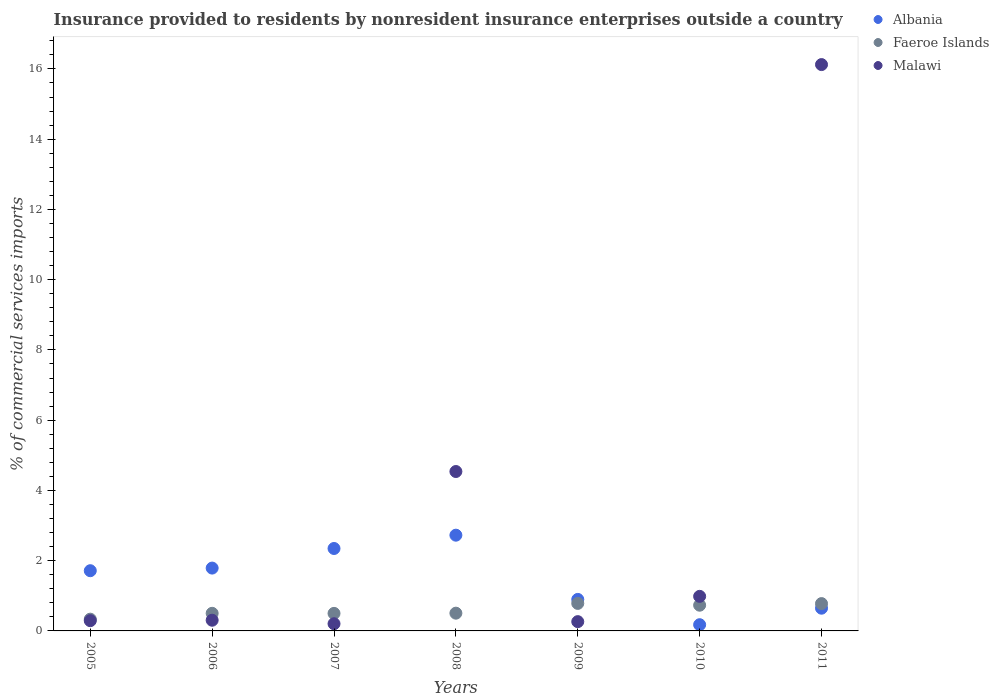How many different coloured dotlines are there?
Offer a very short reply. 3. What is the Insurance provided to residents in Malawi in 2006?
Provide a short and direct response. 0.3. Across all years, what is the maximum Insurance provided to residents in Faeroe Islands?
Keep it short and to the point. 0.78. Across all years, what is the minimum Insurance provided to residents in Faeroe Islands?
Provide a succinct answer. 0.33. In which year was the Insurance provided to residents in Faeroe Islands maximum?
Give a very brief answer. 2009. What is the total Insurance provided to residents in Faeroe Islands in the graph?
Give a very brief answer. 4.13. What is the difference between the Insurance provided to residents in Albania in 2005 and that in 2008?
Your response must be concise. -1.01. What is the difference between the Insurance provided to residents in Albania in 2008 and the Insurance provided to residents in Faeroe Islands in 2007?
Keep it short and to the point. 2.23. What is the average Insurance provided to residents in Malawi per year?
Provide a short and direct response. 3.24. In the year 2007, what is the difference between the Insurance provided to residents in Albania and Insurance provided to residents in Faeroe Islands?
Your response must be concise. 1.85. What is the ratio of the Insurance provided to residents in Faeroe Islands in 2007 to that in 2009?
Keep it short and to the point. 0.64. Is the Insurance provided to residents in Faeroe Islands in 2008 less than that in 2011?
Offer a terse response. Yes. What is the difference between the highest and the second highest Insurance provided to residents in Albania?
Provide a short and direct response. 0.38. What is the difference between the highest and the lowest Insurance provided to residents in Malawi?
Give a very brief answer. 15.92. In how many years, is the Insurance provided to residents in Malawi greater than the average Insurance provided to residents in Malawi taken over all years?
Ensure brevity in your answer.  2. Is the sum of the Insurance provided to residents in Albania in 2005 and 2010 greater than the maximum Insurance provided to residents in Malawi across all years?
Give a very brief answer. No. How many dotlines are there?
Make the answer very short. 3. How many years are there in the graph?
Offer a terse response. 7. Are the values on the major ticks of Y-axis written in scientific E-notation?
Your response must be concise. No. What is the title of the graph?
Offer a very short reply. Insurance provided to residents by nonresident insurance enterprises outside a country. What is the label or title of the X-axis?
Offer a terse response. Years. What is the label or title of the Y-axis?
Keep it short and to the point. % of commercial services imports. What is the % of commercial services imports of Albania in 2005?
Make the answer very short. 1.71. What is the % of commercial services imports of Faeroe Islands in 2005?
Your answer should be compact. 0.33. What is the % of commercial services imports in Malawi in 2005?
Offer a very short reply. 0.29. What is the % of commercial services imports in Albania in 2006?
Provide a short and direct response. 1.79. What is the % of commercial services imports of Faeroe Islands in 2006?
Your response must be concise. 0.5. What is the % of commercial services imports in Malawi in 2006?
Offer a terse response. 0.3. What is the % of commercial services imports of Albania in 2007?
Make the answer very short. 2.35. What is the % of commercial services imports of Faeroe Islands in 2007?
Give a very brief answer. 0.5. What is the % of commercial services imports of Malawi in 2007?
Provide a succinct answer. 0.2. What is the % of commercial services imports of Albania in 2008?
Your response must be concise. 2.73. What is the % of commercial services imports in Faeroe Islands in 2008?
Your answer should be very brief. 0.51. What is the % of commercial services imports of Malawi in 2008?
Ensure brevity in your answer.  4.54. What is the % of commercial services imports of Albania in 2009?
Ensure brevity in your answer.  0.9. What is the % of commercial services imports in Faeroe Islands in 2009?
Your answer should be very brief. 0.78. What is the % of commercial services imports in Malawi in 2009?
Provide a succinct answer. 0.26. What is the % of commercial services imports in Albania in 2010?
Your response must be concise. 0.18. What is the % of commercial services imports of Faeroe Islands in 2010?
Ensure brevity in your answer.  0.73. What is the % of commercial services imports in Malawi in 2010?
Your response must be concise. 0.98. What is the % of commercial services imports of Albania in 2011?
Ensure brevity in your answer.  0.65. What is the % of commercial services imports in Faeroe Islands in 2011?
Offer a very short reply. 0.78. What is the % of commercial services imports of Malawi in 2011?
Offer a terse response. 16.12. Across all years, what is the maximum % of commercial services imports of Albania?
Provide a short and direct response. 2.73. Across all years, what is the maximum % of commercial services imports of Faeroe Islands?
Your response must be concise. 0.78. Across all years, what is the maximum % of commercial services imports of Malawi?
Your response must be concise. 16.12. Across all years, what is the minimum % of commercial services imports of Albania?
Your answer should be very brief. 0.18. Across all years, what is the minimum % of commercial services imports in Faeroe Islands?
Ensure brevity in your answer.  0.33. Across all years, what is the minimum % of commercial services imports of Malawi?
Offer a very short reply. 0.2. What is the total % of commercial services imports in Albania in the graph?
Your answer should be compact. 10.3. What is the total % of commercial services imports in Faeroe Islands in the graph?
Give a very brief answer. 4.13. What is the total % of commercial services imports in Malawi in the graph?
Your answer should be very brief. 22.71. What is the difference between the % of commercial services imports in Albania in 2005 and that in 2006?
Offer a terse response. -0.07. What is the difference between the % of commercial services imports of Faeroe Islands in 2005 and that in 2006?
Your answer should be very brief. -0.17. What is the difference between the % of commercial services imports of Malawi in 2005 and that in 2006?
Offer a terse response. -0.01. What is the difference between the % of commercial services imports in Albania in 2005 and that in 2007?
Provide a short and direct response. -0.63. What is the difference between the % of commercial services imports in Faeroe Islands in 2005 and that in 2007?
Offer a very short reply. -0.16. What is the difference between the % of commercial services imports of Malawi in 2005 and that in 2007?
Offer a very short reply. 0.09. What is the difference between the % of commercial services imports of Albania in 2005 and that in 2008?
Give a very brief answer. -1.01. What is the difference between the % of commercial services imports of Faeroe Islands in 2005 and that in 2008?
Your answer should be compact. -0.17. What is the difference between the % of commercial services imports in Malawi in 2005 and that in 2008?
Your response must be concise. -4.25. What is the difference between the % of commercial services imports in Albania in 2005 and that in 2009?
Give a very brief answer. 0.82. What is the difference between the % of commercial services imports in Faeroe Islands in 2005 and that in 2009?
Offer a very short reply. -0.45. What is the difference between the % of commercial services imports in Malawi in 2005 and that in 2009?
Give a very brief answer. 0.03. What is the difference between the % of commercial services imports in Albania in 2005 and that in 2010?
Provide a succinct answer. 1.54. What is the difference between the % of commercial services imports of Faeroe Islands in 2005 and that in 2010?
Make the answer very short. -0.4. What is the difference between the % of commercial services imports in Malawi in 2005 and that in 2010?
Offer a terse response. -0.69. What is the difference between the % of commercial services imports of Albania in 2005 and that in 2011?
Your response must be concise. 1.07. What is the difference between the % of commercial services imports in Faeroe Islands in 2005 and that in 2011?
Your answer should be compact. -0.44. What is the difference between the % of commercial services imports of Malawi in 2005 and that in 2011?
Give a very brief answer. -15.83. What is the difference between the % of commercial services imports in Albania in 2006 and that in 2007?
Give a very brief answer. -0.56. What is the difference between the % of commercial services imports in Faeroe Islands in 2006 and that in 2007?
Keep it short and to the point. 0. What is the difference between the % of commercial services imports of Malawi in 2006 and that in 2007?
Make the answer very short. 0.1. What is the difference between the % of commercial services imports of Albania in 2006 and that in 2008?
Provide a succinct answer. -0.94. What is the difference between the % of commercial services imports of Faeroe Islands in 2006 and that in 2008?
Make the answer very short. -0. What is the difference between the % of commercial services imports in Malawi in 2006 and that in 2008?
Your answer should be compact. -4.23. What is the difference between the % of commercial services imports in Albania in 2006 and that in 2009?
Offer a terse response. 0.89. What is the difference between the % of commercial services imports in Faeroe Islands in 2006 and that in 2009?
Keep it short and to the point. -0.28. What is the difference between the % of commercial services imports of Malawi in 2006 and that in 2009?
Provide a short and direct response. 0.04. What is the difference between the % of commercial services imports of Albania in 2006 and that in 2010?
Your response must be concise. 1.61. What is the difference between the % of commercial services imports of Faeroe Islands in 2006 and that in 2010?
Offer a terse response. -0.23. What is the difference between the % of commercial services imports of Malawi in 2006 and that in 2010?
Your answer should be very brief. -0.68. What is the difference between the % of commercial services imports in Albania in 2006 and that in 2011?
Provide a short and direct response. 1.14. What is the difference between the % of commercial services imports of Faeroe Islands in 2006 and that in 2011?
Offer a very short reply. -0.28. What is the difference between the % of commercial services imports in Malawi in 2006 and that in 2011?
Make the answer very short. -15.82. What is the difference between the % of commercial services imports in Albania in 2007 and that in 2008?
Give a very brief answer. -0.38. What is the difference between the % of commercial services imports in Faeroe Islands in 2007 and that in 2008?
Keep it short and to the point. -0.01. What is the difference between the % of commercial services imports in Malawi in 2007 and that in 2008?
Make the answer very short. -4.33. What is the difference between the % of commercial services imports in Albania in 2007 and that in 2009?
Your answer should be compact. 1.45. What is the difference between the % of commercial services imports in Faeroe Islands in 2007 and that in 2009?
Offer a terse response. -0.28. What is the difference between the % of commercial services imports of Malawi in 2007 and that in 2009?
Your answer should be very brief. -0.06. What is the difference between the % of commercial services imports in Albania in 2007 and that in 2010?
Make the answer very short. 2.17. What is the difference between the % of commercial services imports of Faeroe Islands in 2007 and that in 2010?
Give a very brief answer. -0.23. What is the difference between the % of commercial services imports of Malawi in 2007 and that in 2010?
Make the answer very short. -0.78. What is the difference between the % of commercial services imports of Albania in 2007 and that in 2011?
Your answer should be very brief. 1.7. What is the difference between the % of commercial services imports of Faeroe Islands in 2007 and that in 2011?
Provide a succinct answer. -0.28. What is the difference between the % of commercial services imports of Malawi in 2007 and that in 2011?
Your response must be concise. -15.92. What is the difference between the % of commercial services imports in Albania in 2008 and that in 2009?
Give a very brief answer. 1.83. What is the difference between the % of commercial services imports in Faeroe Islands in 2008 and that in 2009?
Offer a very short reply. -0.28. What is the difference between the % of commercial services imports of Malawi in 2008 and that in 2009?
Keep it short and to the point. 4.27. What is the difference between the % of commercial services imports of Albania in 2008 and that in 2010?
Provide a succinct answer. 2.55. What is the difference between the % of commercial services imports in Faeroe Islands in 2008 and that in 2010?
Your response must be concise. -0.23. What is the difference between the % of commercial services imports in Malawi in 2008 and that in 2010?
Provide a short and direct response. 3.55. What is the difference between the % of commercial services imports in Albania in 2008 and that in 2011?
Keep it short and to the point. 2.08. What is the difference between the % of commercial services imports of Faeroe Islands in 2008 and that in 2011?
Your response must be concise. -0.27. What is the difference between the % of commercial services imports of Malawi in 2008 and that in 2011?
Keep it short and to the point. -11.59. What is the difference between the % of commercial services imports of Albania in 2009 and that in 2010?
Your answer should be very brief. 0.72. What is the difference between the % of commercial services imports of Faeroe Islands in 2009 and that in 2010?
Provide a short and direct response. 0.05. What is the difference between the % of commercial services imports of Malawi in 2009 and that in 2010?
Provide a short and direct response. -0.72. What is the difference between the % of commercial services imports of Albania in 2009 and that in 2011?
Keep it short and to the point. 0.25. What is the difference between the % of commercial services imports in Faeroe Islands in 2009 and that in 2011?
Give a very brief answer. 0.01. What is the difference between the % of commercial services imports of Malawi in 2009 and that in 2011?
Ensure brevity in your answer.  -15.86. What is the difference between the % of commercial services imports in Albania in 2010 and that in 2011?
Offer a very short reply. -0.47. What is the difference between the % of commercial services imports in Faeroe Islands in 2010 and that in 2011?
Offer a terse response. -0.05. What is the difference between the % of commercial services imports in Malawi in 2010 and that in 2011?
Your response must be concise. -15.14. What is the difference between the % of commercial services imports in Albania in 2005 and the % of commercial services imports in Faeroe Islands in 2006?
Ensure brevity in your answer.  1.21. What is the difference between the % of commercial services imports in Albania in 2005 and the % of commercial services imports in Malawi in 2006?
Keep it short and to the point. 1.41. What is the difference between the % of commercial services imports in Faeroe Islands in 2005 and the % of commercial services imports in Malawi in 2006?
Ensure brevity in your answer.  0.03. What is the difference between the % of commercial services imports in Albania in 2005 and the % of commercial services imports in Faeroe Islands in 2007?
Your answer should be compact. 1.22. What is the difference between the % of commercial services imports in Albania in 2005 and the % of commercial services imports in Malawi in 2007?
Give a very brief answer. 1.51. What is the difference between the % of commercial services imports of Faeroe Islands in 2005 and the % of commercial services imports of Malawi in 2007?
Ensure brevity in your answer.  0.13. What is the difference between the % of commercial services imports of Albania in 2005 and the % of commercial services imports of Faeroe Islands in 2008?
Your answer should be compact. 1.21. What is the difference between the % of commercial services imports in Albania in 2005 and the % of commercial services imports in Malawi in 2008?
Provide a short and direct response. -2.82. What is the difference between the % of commercial services imports in Faeroe Islands in 2005 and the % of commercial services imports in Malawi in 2008?
Your response must be concise. -4.2. What is the difference between the % of commercial services imports of Albania in 2005 and the % of commercial services imports of Faeroe Islands in 2009?
Provide a succinct answer. 0.93. What is the difference between the % of commercial services imports in Albania in 2005 and the % of commercial services imports in Malawi in 2009?
Give a very brief answer. 1.45. What is the difference between the % of commercial services imports in Faeroe Islands in 2005 and the % of commercial services imports in Malawi in 2009?
Ensure brevity in your answer.  0.07. What is the difference between the % of commercial services imports in Albania in 2005 and the % of commercial services imports in Faeroe Islands in 2010?
Ensure brevity in your answer.  0.98. What is the difference between the % of commercial services imports in Albania in 2005 and the % of commercial services imports in Malawi in 2010?
Your answer should be very brief. 0.73. What is the difference between the % of commercial services imports of Faeroe Islands in 2005 and the % of commercial services imports of Malawi in 2010?
Your response must be concise. -0.65. What is the difference between the % of commercial services imports of Albania in 2005 and the % of commercial services imports of Faeroe Islands in 2011?
Offer a terse response. 0.94. What is the difference between the % of commercial services imports in Albania in 2005 and the % of commercial services imports in Malawi in 2011?
Your answer should be very brief. -14.41. What is the difference between the % of commercial services imports of Faeroe Islands in 2005 and the % of commercial services imports of Malawi in 2011?
Your answer should be very brief. -15.79. What is the difference between the % of commercial services imports of Albania in 2006 and the % of commercial services imports of Faeroe Islands in 2007?
Your response must be concise. 1.29. What is the difference between the % of commercial services imports of Albania in 2006 and the % of commercial services imports of Malawi in 2007?
Your response must be concise. 1.58. What is the difference between the % of commercial services imports of Faeroe Islands in 2006 and the % of commercial services imports of Malawi in 2007?
Your answer should be compact. 0.3. What is the difference between the % of commercial services imports of Albania in 2006 and the % of commercial services imports of Faeroe Islands in 2008?
Keep it short and to the point. 1.28. What is the difference between the % of commercial services imports of Albania in 2006 and the % of commercial services imports of Malawi in 2008?
Ensure brevity in your answer.  -2.75. What is the difference between the % of commercial services imports in Faeroe Islands in 2006 and the % of commercial services imports in Malawi in 2008?
Provide a short and direct response. -4.04. What is the difference between the % of commercial services imports in Albania in 2006 and the % of commercial services imports in Faeroe Islands in 2009?
Ensure brevity in your answer.  1.01. What is the difference between the % of commercial services imports in Albania in 2006 and the % of commercial services imports in Malawi in 2009?
Offer a very short reply. 1.52. What is the difference between the % of commercial services imports in Faeroe Islands in 2006 and the % of commercial services imports in Malawi in 2009?
Keep it short and to the point. 0.24. What is the difference between the % of commercial services imports of Albania in 2006 and the % of commercial services imports of Faeroe Islands in 2010?
Provide a short and direct response. 1.06. What is the difference between the % of commercial services imports in Albania in 2006 and the % of commercial services imports in Malawi in 2010?
Ensure brevity in your answer.  0.8. What is the difference between the % of commercial services imports of Faeroe Islands in 2006 and the % of commercial services imports of Malawi in 2010?
Your response must be concise. -0.48. What is the difference between the % of commercial services imports of Albania in 2006 and the % of commercial services imports of Faeroe Islands in 2011?
Your answer should be compact. 1.01. What is the difference between the % of commercial services imports of Albania in 2006 and the % of commercial services imports of Malawi in 2011?
Give a very brief answer. -14.34. What is the difference between the % of commercial services imports of Faeroe Islands in 2006 and the % of commercial services imports of Malawi in 2011?
Provide a succinct answer. -15.62. What is the difference between the % of commercial services imports in Albania in 2007 and the % of commercial services imports in Faeroe Islands in 2008?
Ensure brevity in your answer.  1.84. What is the difference between the % of commercial services imports of Albania in 2007 and the % of commercial services imports of Malawi in 2008?
Keep it short and to the point. -2.19. What is the difference between the % of commercial services imports in Faeroe Islands in 2007 and the % of commercial services imports in Malawi in 2008?
Offer a very short reply. -4.04. What is the difference between the % of commercial services imports of Albania in 2007 and the % of commercial services imports of Faeroe Islands in 2009?
Offer a very short reply. 1.56. What is the difference between the % of commercial services imports of Albania in 2007 and the % of commercial services imports of Malawi in 2009?
Offer a terse response. 2.08. What is the difference between the % of commercial services imports in Faeroe Islands in 2007 and the % of commercial services imports in Malawi in 2009?
Make the answer very short. 0.23. What is the difference between the % of commercial services imports of Albania in 2007 and the % of commercial services imports of Faeroe Islands in 2010?
Make the answer very short. 1.61. What is the difference between the % of commercial services imports of Albania in 2007 and the % of commercial services imports of Malawi in 2010?
Offer a terse response. 1.36. What is the difference between the % of commercial services imports of Faeroe Islands in 2007 and the % of commercial services imports of Malawi in 2010?
Your answer should be compact. -0.49. What is the difference between the % of commercial services imports of Albania in 2007 and the % of commercial services imports of Faeroe Islands in 2011?
Offer a terse response. 1.57. What is the difference between the % of commercial services imports of Albania in 2007 and the % of commercial services imports of Malawi in 2011?
Your response must be concise. -13.78. What is the difference between the % of commercial services imports in Faeroe Islands in 2007 and the % of commercial services imports in Malawi in 2011?
Give a very brief answer. -15.62. What is the difference between the % of commercial services imports of Albania in 2008 and the % of commercial services imports of Faeroe Islands in 2009?
Make the answer very short. 1.94. What is the difference between the % of commercial services imports of Albania in 2008 and the % of commercial services imports of Malawi in 2009?
Make the answer very short. 2.46. What is the difference between the % of commercial services imports in Faeroe Islands in 2008 and the % of commercial services imports in Malawi in 2009?
Offer a very short reply. 0.24. What is the difference between the % of commercial services imports in Albania in 2008 and the % of commercial services imports in Faeroe Islands in 2010?
Your response must be concise. 1.99. What is the difference between the % of commercial services imports of Albania in 2008 and the % of commercial services imports of Malawi in 2010?
Your response must be concise. 1.74. What is the difference between the % of commercial services imports of Faeroe Islands in 2008 and the % of commercial services imports of Malawi in 2010?
Your answer should be very brief. -0.48. What is the difference between the % of commercial services imports of Albania in 2008 and the % of commercial services imports of Faeroe Islands in 2011?
Offer a terse response. 1.95. What is the difference between the % of commercial services imports in Albania in 2008 and the % of commercial services imports in Malawi in 2011?
Offer a terse response. -13.4. What is the difference between the % of commercial services imports of Faeroe Islands in 2008 and the % of commercial services imports of Malawi in 2011?
Make the answer very short. -15.62. What is the difference between the % of commercial services imports in Albania in 2009 and the % of commercial services imports in Faeroe Islands in 2010?
Keep it short and to the point. 0.17. What is the difference between the % of commercial services imports of Albania in 2009 and the % of commercial services imports of Malawi in 2010?
Provide a short and direct response. -0.09. What is the difference between the % of commercial services imports of Faeroe Islands in 2009 and the % of commercial services imports of Malawi in 2010?
Provide a succinct answer. -0.2. What is the difference between the % of commercial services imports in Albania in 2009 and the % of commercial services imports in Faeroe Islands in 2011?
Offer a very short reply. 0.12. What is the difference between the % of commercial services imports in Albania in 2009 and the % of commercial services imports in Malawi in 2011?
Ensure brevity in your answer.  -15.23. What is the difference between the % of commercial services imports in Faeroe Islands in 2009 and the % of commercial services imports in Malawi in 2011?
Your answer should be compact. -15.34. What is the difference between the % of commercial services imports in Albania in 2010 and the % of commercial services imports in Faeroe Islands in 2011?
Provide a short and direct response. -0.6. What is the difference between the % of commercial services imports of Albania in 2010 and the % of commercial services imports of Malawi in 2011?
Offer a terse response. -15.95. What is the difference between the % of commercial services imports in Faeroe Islands in 2010 and the % of commercial services imports in Malawi in 2011?
Offer a terse response. -15.39. What is the average % of commercial services imports in Albania per year?
Your answer should be compact. 1.47. What is the average % of commercial services imports in Faeroe Islands per year?
Your answer should be compact. 0.59. What is the average % of commercial services imports in Malawi per year?
Keep it short and to the point. 3.24. In the year 2005, what is the difference between the % of commercial services imports of Albania and % of commercial services imports of Faeroe Islands?
Keep it short and to the point. 1.38. In the year 2005, what is the difference between the % of commercial services imports of Albania and % of commercial services imports of Malawi?
Offer a very short reply. 1.42. In the year 2005, what is the difference between the % of commercial services imports of Faeroe Islands and % of commercial services imports of Malawi?
Keep it short and to the point. 0.04. In the year 2006, what is the difference between the % of commercial services imports of Albania and % of commercial services imports of Faeroe Islands?
Provide a succinct answer. 1.29. In the year 2006, what is the difference between the % of commercial services imports of Albania and % of commercial services imports of Malawi?
Your response must be concise. 1.48. In the year 2006, what is the difference between the % of commercial services imports of Faeroe Islands and % of commercial services imports of Malawi?
Give a very brief answer. 0.2. In the year 2007, what is the difference between the % of commercial services imports of Albania and % of commercial services imports of Faeroe Islands?
Give a very brief answer. 1.85. In the year 2007, what is the difference between the % of commercial services imports in Albania and % of commercial services imports in Malawi?
Make the answer very short. 2.14. In the year 2007, what is the difference between the % of commercial services imports in Faeroe Islands and % of commercial services imports in Malawi?
Provide a short and direct response. 0.29. In the year 2008, what is the difference between the % of commercial services imports of Albania and % of commercial services imports of Faeroe Islands?
Your answer should be very brief. 2.22. In the year 2008, what is the difference between the % of commercial services imports of Albania and % of commercial services imports of Malawi?
Keep it short and to the point. -1.81. In the year 2008, what is the difference between the % of commercial services imports in Faeroe Islands and % of commercial services imports in Malawi?
Ensure brevity in your answer.  -4.03. In the year 2009, what is the difference between the % of commercial services imports in Albania and % of commercial services imports in Faeroe Islands?
Provide a short and direct response. 0.11. In the year 2009, what is the difference between the % of commercial services imports in Albania and % of commercial services imports in Malawi?
Offer a very short reply. 0.63. In the year 2009, what is the difference between the % of commercial services imports of Faeroe Islands and % of commercial services imports of Malawi?
Ensure brevity in your answer.  0.52. In the year 2010, what is the difference between the % of commercial services imports of Albania and % of commercial services imports of Faeroe Islands?
Your response must be concise. -0.56. In the year 2010, what is the difference between the % of commercial services imports in Albania and % of commercial services imports in Malawi?
Ensure brevity in your answer.  -0.81. In the year 2010, what is the difference between the % of commercial services imports in Faeroe Islands and % of commercial services imports in Malawi?
Ensure brevity in your answer.  -0.25. In the year 2011, what is the difference between the % of commercial services imports of Albania and % of commercial services imports of Faeroe Islands?
Provide a succinct answer. -0.13. In the year 2011, what is the difference between the % of commercial services imports in Albania and % of commercial services imports in Malawi?
Keep it short and to the point. -15.48. In the year 2011, what is the difference between the % of commercial services imports in Faeroe Islands and % of commercial services imports in Malawi?
Offer a very short reply. -15.35. What is the ratio of the % of commercial services imports in Albania in 2005 to that in 2006?
Offer a terse response. 0.96. What is the ratio of the % of commercial services imports of Faeroe Islands in 2005 to that in 2006?
Provide a succinct answer. 0.67. What is the ratio of the % of commercial services imports of Malawi in 2005 to that in 2006?
Your answer should be very brief. 0.96. What is the ratio of the % of commercial services imports in Albania in 2005 to that in 2007?
Keep it short and to the point. 0.73. What is the ratio of the % of commercial services imports in Faeroe Islands in 2005 to that in 2007?
Your answer should be compact. 0.67. What is the ratio of the % of commercial services imports in Malawi in 2005 to that in 2007?
Give a very brief answer. 1.42. What is the ratio of the % of commercial services imports of Albania in 2005 to that in 2008?
Keep it short and to the point. 0.63. What is the ratio of the % of commercial services imports in Faeroe Islands in 2005 to that in 2008?
Your answer should be very brief. 0.66. What is the ratio of the % of commercial services imports of Malawi in 2005 to that in 2008?
Offer a very short reply. 0.06. What is the ratio of the % of commercial services imports in Albania in 2005 to that in 2009?
Give a very brief answer. 1.91. What is the ratio of the % of commercial services imports in Faeroe Islands in 2005 to that in 2009?
Make the answer very short. 0.43. What is the ratio of the % of commercial services imports of Malawi in 2005 to that in 2009?
Provide a short and direct response. 1.1. What is the ratio of the % of commercial services imports in Albania in 2005 to that in 2010?
Ensure brevity in your answer.  9.68. What is the ratio of the % of commercial services imports of Faeroe Islands in 2005 to that in 2010?
Provide a succinct answer. 0.46. What is the ratio of the % of commercial services imports in Malawi in 2005 to that in 2010?
Provide a succinct answer. 0.3. What is the ratio of the % of commercial services imports in Albania in 2005 to that in 2011?
Offer a very short reply. 2.65. What is the ratio of the % of commercial services imports in Faeroe Islands in 2005 to that in 2011?
Keep it short and to the point. 0.43. What is the ratio of the % of commercial services imports of Malawi in 2005 to that in 2011?
Your answer should be very brief. 0.02. What is the ratio of the % of commercial services imports of Albania in 2006 to that in 2007?
Provide a succinct answer. 0.76. What is the ratio of the % of commercial services imports in Malawi in 2006 to that in 2007?
Offer a terse response. 1.49. What is the ratio of the % of commercial services imports of Albania in 2006 to that in 2008?
Keep it short and to the point. 0.66. What is the ratio of the % of commercial services imports of Faeroe Islands in 2006 to that in 2008?
Your answer should be very brief. 0.99. What is the ratio of the % of commercial services imports of Malawi in 2006 to that in 2008?
Offer a terse response. 0.07. What is the ratio of the % of commercial services imports of Albania in 2006 to that in 2009?
Your answer should be compact. 1.99. What is the ratio of the % of commercial services imports in Faeroe Islands in 2006 to that in 2009?
Provide a short and direct response. 0.64. What is the ratio of the % of commercial services imports in Malawi in 2006 to that in 2009?
Provide a short and direct response. 1.15. What is the ratio of the % of commercial services imports of Albania in 2006 to that in 2010?
Provide a succinct answer. 10.1. What is the ratio of the % of commercial services imports of Faeroe Islands in 2006 to that in 2010?
Keep it short and to the point. 0.68. What is the ratio of the % of commercial services imports in Malawi in 2006 to that in 2010?
Your answer should be very brief. 0.31. What is the ratio of the % of commercial services imports in Albania in 2006 to that in 2011?
Provide a succinct answer. 2.76. What is the ratio of the % of commercial services imports in Faeroe Islands in 2006 to that in 2011?
Provide a succinct answer. 0.64. What is the ratio of the % of commercial services imports of Malawi in 2006 to that in 2011?
Offer a very short reply. 0.02. What is the ratio of the % of commercial services imports of Albania in 2007 to that in 2008?
Provide a short and direct response. 0.86. What is the ratio of the % of commercial services imports in Malawi in 2007 to that in 2008?
Provide a short and direct response. 0.05. What is the ratio of the % of commercial services imports of Albania in 2007 to that in 2009?
Provide a succinct answer. 2.62. What is the ratio of the % of commercial services imports of Faeroe Islands in 2007 to that in 2009?
Your answer should be compact. 0.64. What is the ratio of the % of commercial services imports of Malawi in 2007 to that in 2009?
Make the answer very short. 0.77. What is the ratio of the % of commercial services imports in Albania in 2007 to that in 2010?
Give a very brief answer. 13.25. What is the ratio of the % of commercial services imports of Faeroe Islands in 2007 to that in 2010?
Provide a short and direct response. 0.68. What is the ratio of the % of commercial services imports in Malawi in 2007 to that in 2010?
Provide a short and direct response. 0.21. What is the ratio of the % of commercial services imports in Albania in 2007 to that in 2011?
Offer a very short reply. 3.63. What is the ratio of the % of commercial services imports of Faeroe Islands in 2007 to that in 2011?
Your response must be concise. 0.64. What is the ratio of the % of commercial services imports of Malawi in 2007 to that in 2011?
Keep it short and to the point. 0.01. What is the ratio of the % of commercial services imports of Albania in 2008 to that in 2009?
Provide a succinct answer. 3.04. What is the ratio of the % of commercial services imports of Faeroe Islands in 2008 to that in 2009?
Give a very brief answer. 0.65. What is the ratio of the % of commercial services imports of Malawi in 2008 to that in 2009?
Provide a succinct answer. 17.18. What is the ratio of the % of commercial services imports in Albania in 2008 to that in 2010?
Ensure brevity in your answer.  15.39. What is the ratio of the % of commercial services imports of Faeroe Islands in 2008 to that in 2010?
Keep it short and to the point. 0.69. What is the ratio of the % of commercial services imports in Malawi in 2008 to that in 2010?
Your answer should be compact. 4.61. What is the ratio of the % of commercial services imports in Albania in 2008 to that in 2011?
Your answer should be very brief. 4.21. What is the ratio of the % of commercial services imports of Faeroe Islands in 2008 to that in 2011?
Your answer should be compact. 0.65. What is the ratio of the % of commercial services imports of Malawi in 2008 to that in 2011?
Provide a succinct answer. 0.28. What is the ratio of the % of commercial services imports of Albania in 2009 to that in 2010?
Provide a short and direct response. 5.07. What is the ratio of the % of commercial services imports of Faeroe Islands in 2009 to that in 2010?
Provide a succinct answer. 1.07. What is the ratio of the % of commercial services imports in Malawi in 2009 to that in 2010?
Offer a terse response. 0.27. What is the ratio of the % of commercial services imports of Albania in 2009 to that in 2011?
Ensure brevity in your answer.  1.39. What is the ratio of the % of commercial services imports in Faeroe Islands in 2009 to that in 2011?
Your answer should be very brief. 1.01. What is the ratio of the % of commercial services imports of Malawi in 2009 to that in 2011?
Provide a short and direct response. 0.02. What is the ratio of the % of commercial services imports in Albania in 2010 to that in 2011?
Provide a short and direct response. 0.27. What is the ratio of the % of commercial services imports of Faeroe Islands in 2010 to that in 2011?
Offer a very short reply. 0.94. What is the ratio of the % of commercial services imports in Malawi in 2010 to that in 2011?
Your response must be concise. 0.06. What is the difference between the highest and the second highest % of commercial services imports of Albania?
Provide a succinct answer. 0.38. What is the difference between the highest and the second highest % of commercial services imports of Faeroe Islands?
Your response must be concise. 0.01. What is the difference between the highest and the second highest % of commercial services imports in Malawi?
Offer a very short reply. 11.59. What is the difference between the highest and the lowest % of commercial services imports of Albania?
Give a very brief answer. 2.55. What is the difference between the highest and the lowest % of commercial services imports of Faeroe Islands?
Make the answer very short. 0.45. What is the difference between the highest and the lowest % of commercial services imports of Malawi?
Give a very brief answer. 15.92. 